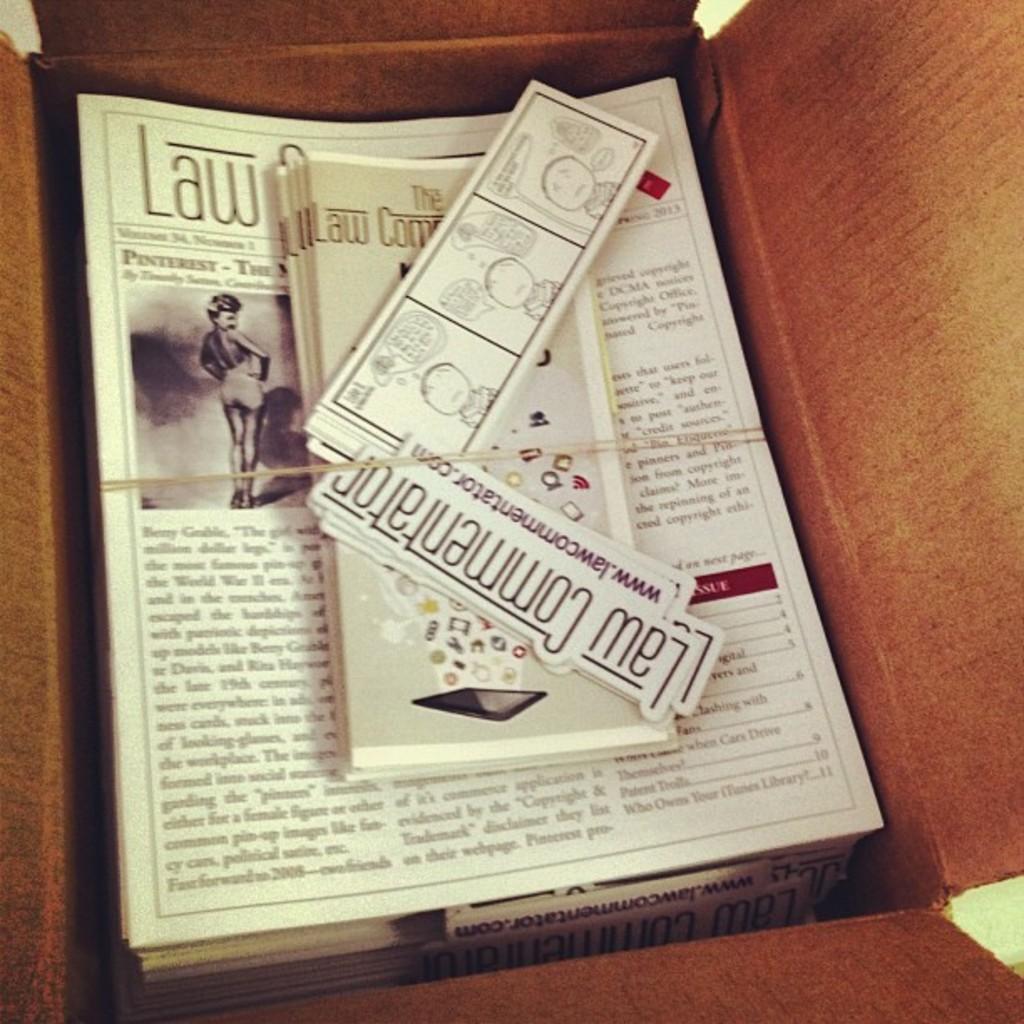What three letter word is in the top left corner of the flyer?
Give a very brief answer. Law. How many columns are there on the flyer?
Provide a short and direct response. Answering does not require reading text in the image. 